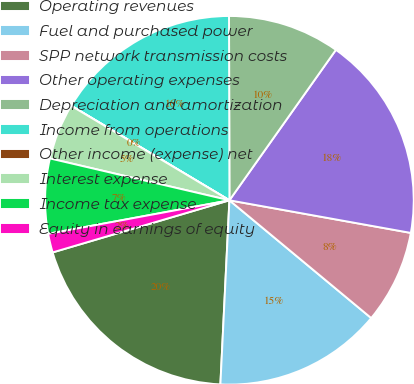Convert chart to OTSL. <chart><loc_0><loc_0><loc_500><loc_500><pie_chart><fcel>Operating revenues<fcel>Fuel and purchased power<fcel>SPP network transmission costs<fcel>Other operating expenses<fcel>Depreciation and amortization<fcel>Income from operations<fcel>Other income (expense) net<fcel>Interest expense<fcel>Income tax expense<fcel>Equity in earnings of equity<nl><fcel>19.66%<fcel>14.75%<fcel>8.2%<fcel>18.03%<fcel>9.84%<fcel>16.39%<fcel>0.01%<fcel>4.92%<fcel>6.56%<fcel>1.65%<nl></chart> 